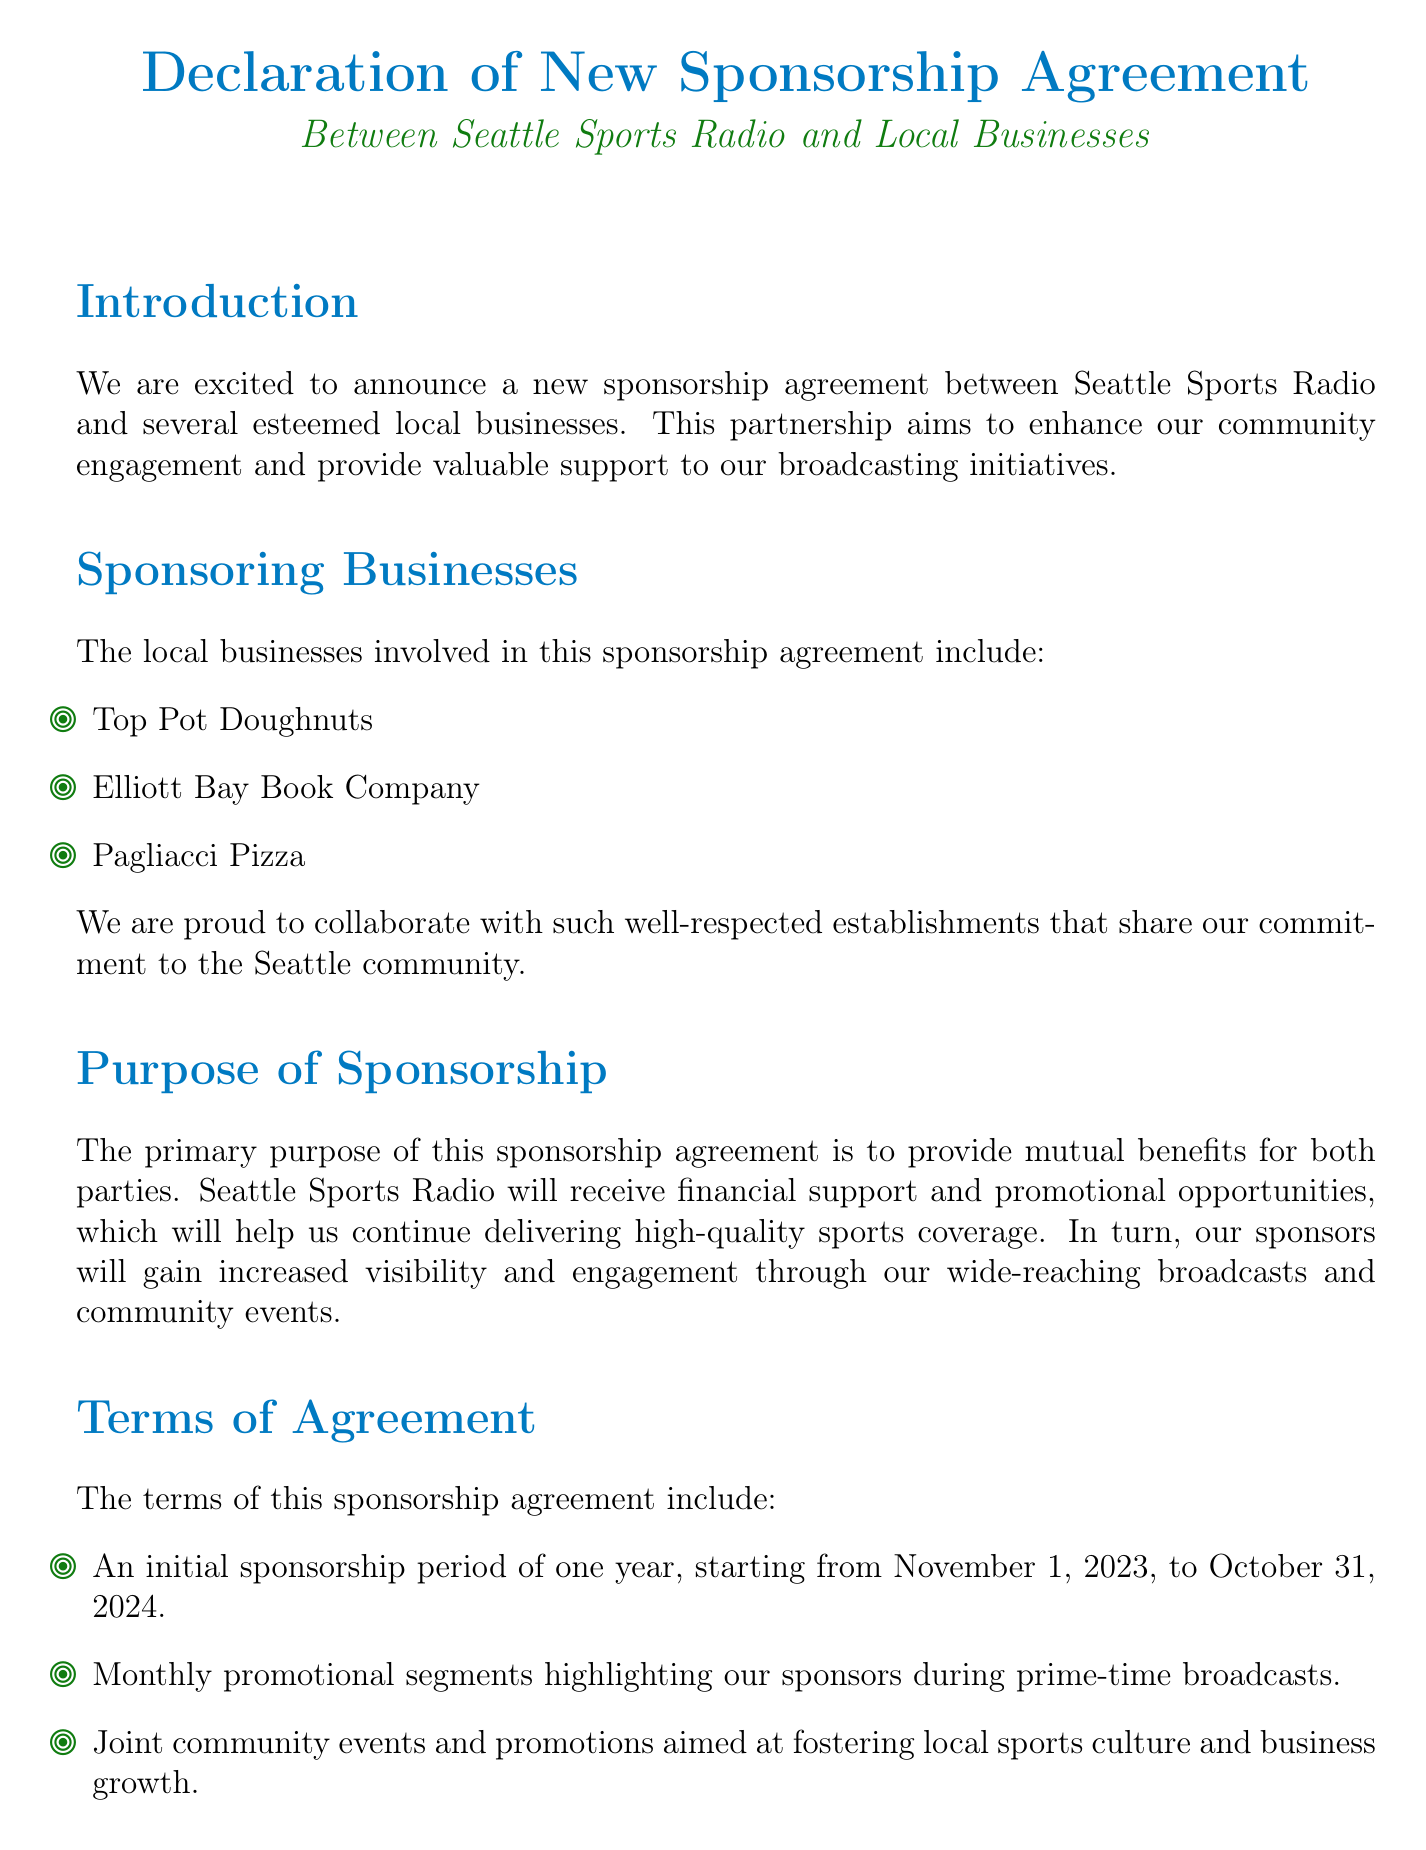What is the primary purpose of the sponsorship? The primary purpose of the sponsorship agreement is to provide mutual benefits for both parties.
Answer: Mutual benefits When does the sponsorship period start? The document specifies the start date of the sponsorship period.
Answer: November 1, 2023 Which business is owned by John Schilling? John Schilling is listed as the owner in the signatories section of the document.
Answer: Top Pot Doughnuts How long is the initial sponsorship period? The document outlines the duration of the initial sponsorship period.
Answer: One year What type of promotional segments will Seattle Sports Radio provide? The document indicates the type of segments that will be highlighted during broadcasts.
Answer: Monthly promotional segments What is the date of the document? The conclusion section states the date when this declaration was signed.
Answer: October 25, 2023 Which local business is represented by Emily Davis? Emily Davis is mentioned in the signatories section of the document.
Answer: Pagliacci Pizza How many sponsoring businesses are listed? The document lists the number of sponsoring businesses involved in the agreement.
Answer: Three 